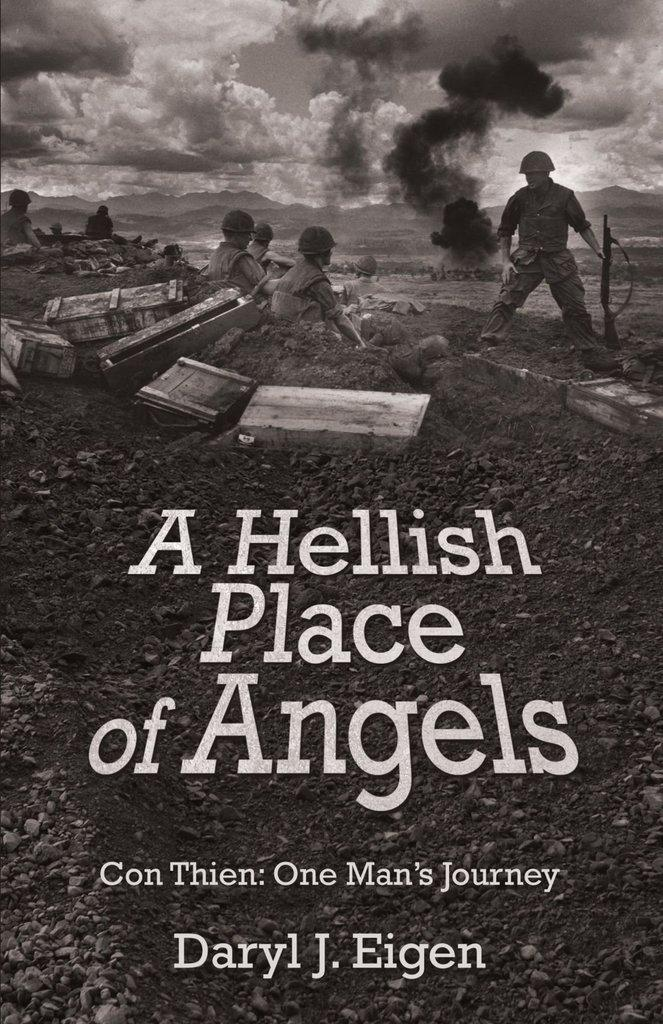Provide a one-sentence caption for the provided image. Daryl Eigen's book, A Hellish Place of Angels, bears a grim war scene on the cover. 